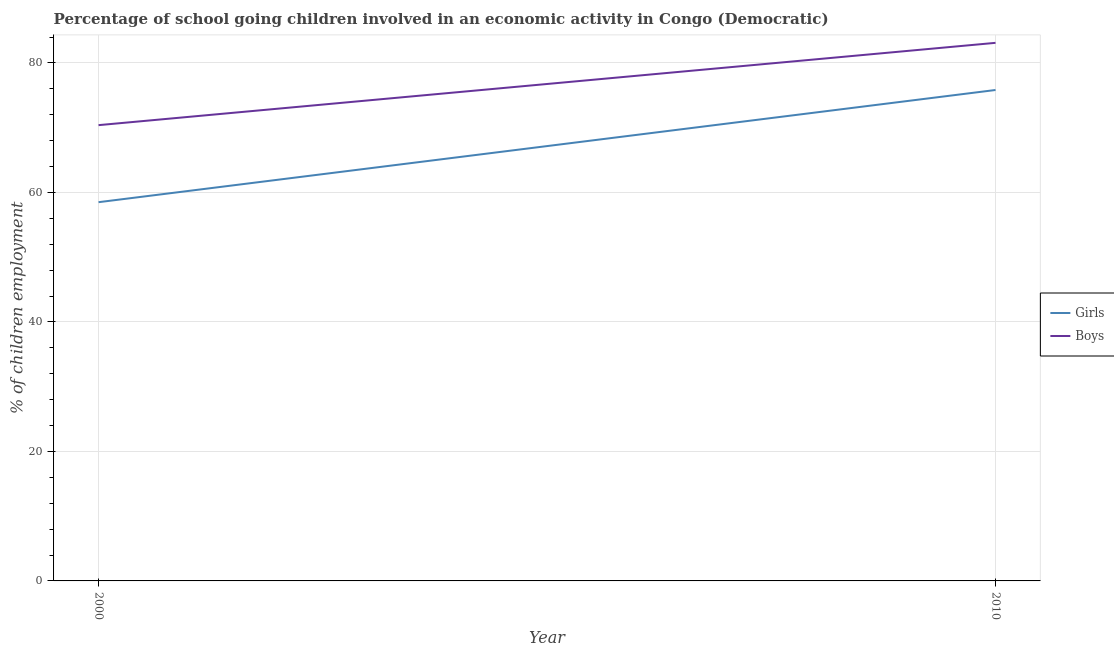Is the number of lines equal to the number of legend labels?
Give a very brief answer. Yes. What is the percentage of school going boys in 2000?
Provide a succinct answer. 70.4. Across all years, what is the maximum percentage of school going boys?
Give a very brief answer. 83.11. Across all years, what is the minimum percentage of school going boys?
Offer a terse response. 70.4. In which year was the percentage of school going boys maximum?
Your answer should be very brief. 2010. In which year was the percentage of school going boys minimum?
Offer a terse response. 2000. What is the total percentage of school going boys in the graph?
Make the answer very short. 153.51. What is the difference between the percentage of school going girls in 2000 and that in 2010?
Offer a very short reply. -17.33. What is the difference between the percentage of school going girls in 2010 and the percentage of school going boys in 2000?
Make the answer very short. 5.43. What is the average percentage of school going girls per year?
Give a very brief answer. 67.16. In the year 2010, what is the difference between the percentage of school going boys and percentage of school going girls?
Provide a succinct answer. 7.29. In how many years, is the percentage of school going girls greater than 12 %?
Offer a very short reply. 2. What is the ratio of the percentage of school going boys in 2000 to that in 2010?
Your response must be concise. 0.85. Is the percentage of school going girls in 2000 less than that in 2010?
Your answer should be compact. Yes. In how many years, is the percentage of school going boys greater than the average percentage of school going boys taken over all years?
Your response must be concise. 1. Does the percentage of school going boys monotonically increase over the years?
Offer a terse response. Yes. Is the percentage of school going girls strictly greater than the percentage of school going boys over the years?
Keep it short and to the point. No. How many lines are there?
Your answer should be very brief. 2. What is the difference between two consecutive major ticks on the Y-axis?
Provide a succinct answer. 20. Does the graph contain grids?
Ensure brevity in your answer.  Yes. How many legend labels are there?
Provide a short and direct response. 2. How are the legend labels stacked?
Provide a short and direct response. Vertical. What is the title of the graph?
Provide a short and direct response. Percentage of school going children involved in an economic activity in Congo (Democratic). Does "Underweight" appear as one of the legend labels in the graph?
Provide a succinct answer. No. What is the label or title of the Y-axis?
Make the answer very short. % of children employment. What is the % of children employment in Girls in 2000?
Ensure brevity in your answer.  58.5. What is the % of children employment in Boys in 2000?
Ensure brevity in your answer.  70.4. What is the % of children employment in Girls in 2010?
Your response must be concise. 75.83. What is the % of children employment in Boys in 2010?
Your response must be concise. 83.11. Across all years, what is the maximum % of children employment of Girls?
Provide a succinct answer. 75.83. Across all years, what is the maximum % of children employment in Boys?
Ensure brevity in your answer.  83.11. Across all years, what is the minimum % of children employment in Girls?
Your response must be concise. 58.5. Across all years, what is the minimum % of children employment of Boys?
Your answer should be compact. 70.4. What is the total % of children employment of Girls in the graph?
Offer a terse response. 134.33. What is the total % of children employment in Boys in the graph?
Offer a terse response. 153.51. What is the difference between the % of children employment in Girls in 2000 and that in 2010?
Ensure brevity in your answer.  -17.33. What is the difference between the % of children employment in Boys in 2000 and that in 2010?
Offer a very short reply. -12.71. What is the difference between the % of children employment of Girls in 2000 and the % of children employment of Boys in 2010?
Your answer should be compact. -24.61. What is the average % of children employment of Girls per year?
Offer a very short reply. 67.16. What is the average % of children employment of Boys per year?
Keep it short and to the point. 76.76. In the year 2000, what is the difference between the % of children employment of Girls and % of children employment of Boys?
Your answer should be very brief. -11.9. In the year 2010, what is the difference between the % of children employment of Girls and % of children employment of Boys?
Offer a very short reply. -7.29. What is the ratio of the % of children employment of Girls in 2000 to that in 2010?
Ensure brevity in your answer.  0.77. What is the ratio of the % of children employment of Boys in 2000 to that in 2010?
Your answer should be compact. 0.85. What is the difference between the highest and the second highest % of children employment in Girls?
Your response must be concise. 17.33. What is the difference between the highest and the second highest % of children employment of Boys?
Offer a terse response. 12.71. What is the difference between the highest and the lowest % of children employment of Girls?
Ensure brevity in your answer.  17.33. What is the difference between the highest and the lowest % of children employment of Boys?
Provide a succinct answer. 12.71. 